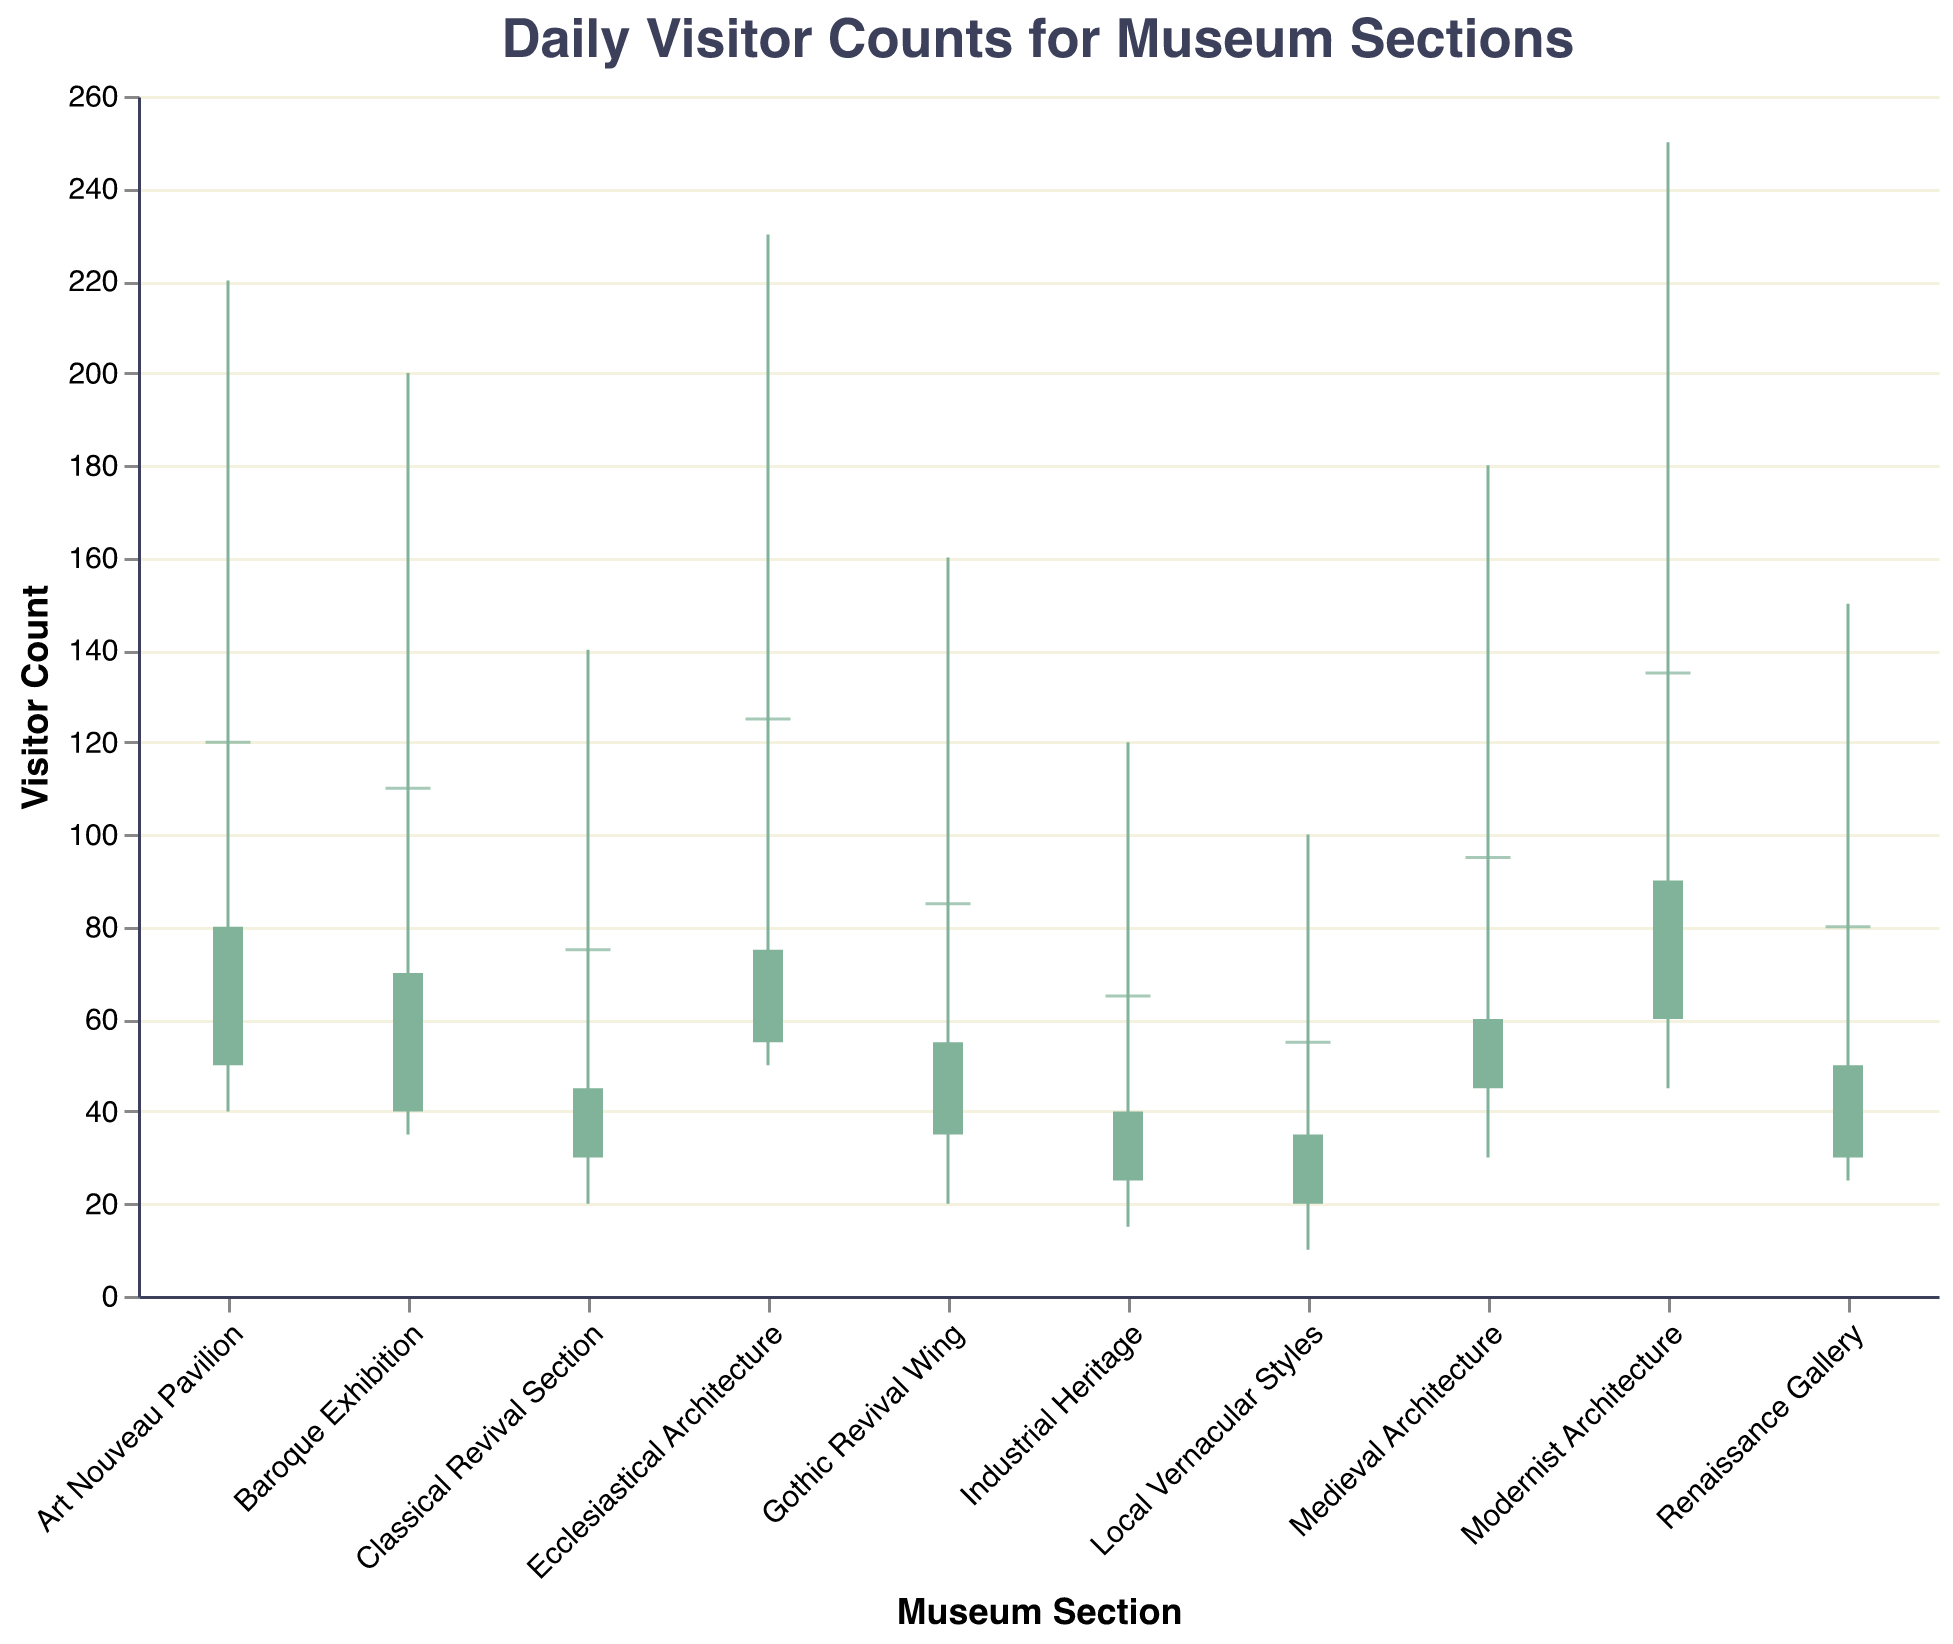What's the title of the chart? The title is typically displayed at the top of the chart. Here, it states "Daily Visitor Counts for Museum Sections".
Answer: Daily Visitor Counts for Museum Sections Which museum section had the highest peak attendance? The highest peak attendance corresponds to the highest "High" value in the chart. In this case, the "Modernist Architecture" section had a peak attendance of 250 visitors.
Answer: Modernist Architecture What is the range of visitor counts for the "Gothic Revival Wing"? The range is calculated by subtracting the lowest attendance (Low) from the highest attendance (High). For "Gothic Revival Wing", the high is 160 and the low is 20. So, the range is 160 - 20.
Answer: 140 Which section had the lowest average attendance? The lowest average attendance corresponds to the smallest "Average" value. Here, the "Local Vernacular Styles" section had the lowest average attendance of 55 visitors.
Answer: Local Vernacular Styles Between the "Art Nouveau Pavilion" and "Ecclesiastical Architecture", which had a higher opening attendance? Compare the "Opening" values for both sections. "Art Nouveau Pavilion" has an opening attendance of 50, while "Ecclesiastical Architecture" has 55.
Answer: Ecclesiastical Architecture What's the difference in closing attendance between "Medieval Architecture" and "Industrial Heritage"? Subtract the closing attendance of "Industrial Heritage" from that of "Medieval Architecture". Here, it's 60 (Medieval Architecture) - 40 (Industrial Heritage).
Answer: 20 Which sections had a closing attendance less than their opening attendance? Observe the bars where the top of the bar (opening) is higher than the bottom (closing). These sections are "Medieval Architecture", "Renaissance Gallery", "Gothic Revival Wing", "Industrial Heritage", "Local Vernacular Styles", and "Classical Revival Section".
Answer: Medieval Architecture, Renaissance Gallery, Gothic Revival Wing, Industrial Heritage, Local Vernacular Styles, Classical Revival Section For the "Baroque Exhibition", how many visitors ranged from the opening to closing attendance? Calculate the difference between the closing and opening attendance. Baroque Exhibition had 70 visitors at closing and 40 at opening. So, 70 - 40.
Answer: 30 Which museum section had the smallest difference between its highest and lowest visitor counts? Find the smallest difference between High and Low values across all sections. Here, "Local Vernacular Styles" has the smallest difference: 100 - 10.
Answer: Local Vernacular Styles In terms of average attendance, is "Art Nouveau Pavilion" above or below the overall average of all sections? First, calculate the overall average: (95 + 80 + 110 + 85 + 120 + 135 + 65 + 55 + 125 + 75) / 10 = 94.5. "Art Nouveau Pavilion" had an average of 120, which is above the overall average.
Answer: Above 